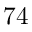Convert formula to latex. <formula><loc_0><loc_0><loc_500><loc_500>7 4</formula> 